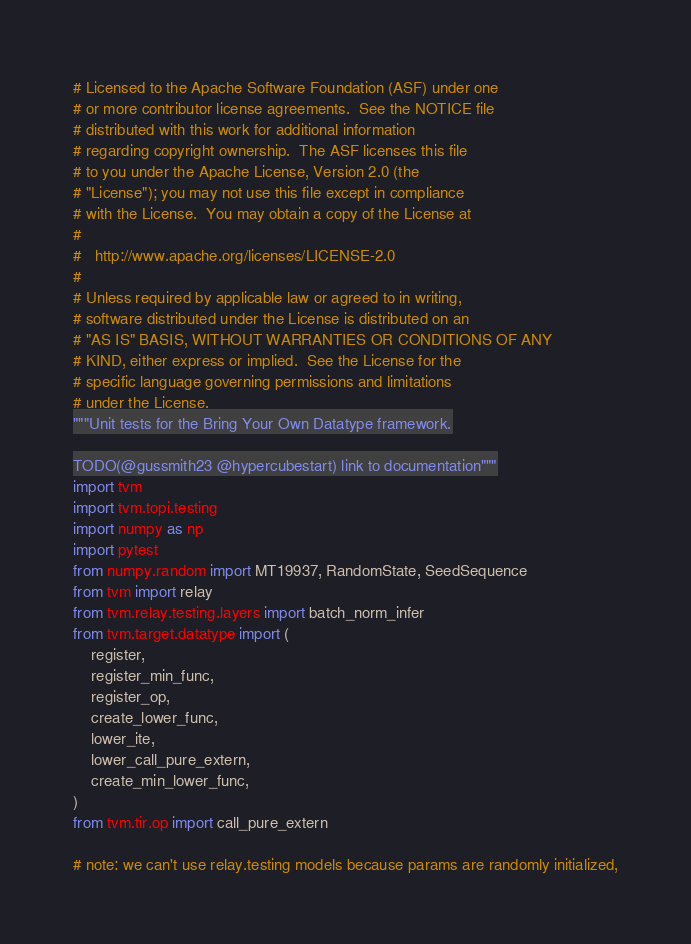<code> <loc_0><loc_0><loc_500><loc_500><_Python_># Licensed to the Apache Software Foundation (ASF) under one
# or more contributor license agreements.  See the NOTICE file
# distributed with this work for additional information
# regarding copyright ownership.  The ASF licenses this file
# to you under the Apache License, Version 2.0 (the
# "License"); you may not use this file except in compliance
# with the License.  You may obtain a copy of the License at
#
#   http://www.apache.org/licenses/LICENSE-2.0
#
# Unless required by applicable law or agreed to in writing,
# software distributed under the License is distributed on an
# "AS IS" BASIS, WITHOUT WARRANTIES OR CONDITIONS OF ANY
# KIND, either express or implied.  See the License for the
# specific language governing permissions and limitations
# under the License.
"""Unit tests for the Bring Your Own Datatype framework.

TODO(@gussmith23 @hypercubestart) link to documentation"""
import tvm
import tvm.topi.testing
import numpy as np
import pytest
from numpy.random import MT19937, RandomState, SeedSequence
from tvm import relay
from tvm.relay.testing.layers import batch_norm_infer
from tvm.target.datatype import (
    register,
    register_min_func,
    register_op,
    create_lower_func,
    lower_ite,
    lower_call_pure_extern,
    create_min_lower_func,
)
from tvm.tir.op import call_pure_extern

# note: we can't use relay.testing models because params are randomly initialized,</code> 